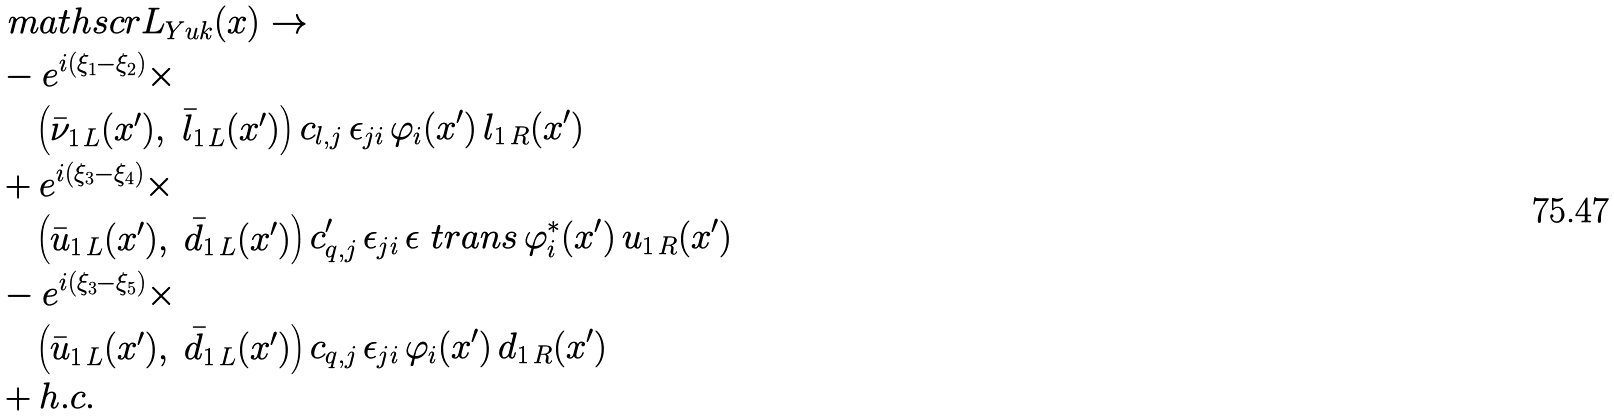Convert formula to latex. <formula><loc_0><loc_0><loc_500><loc_500>& \ m a t h s c r { L } _ { Y u k } ( x ) \rightarrow \\ & - e ^ { i ( \xi _ { 1 } - \xi _ { 2 } ) } \times \\ & \quad \begin{pmatrix} \bar { \nu } _ { 1 \, L } ( x ^ { \prime } ) , & \bar { l } _ { 1 \, L } ( x ^ { \prime } ) \end{pmatrix} c _ { l , j } \, \epsilon _ { j i } \, \varphi _ { i } ( x ^ { \prime } ) \, l _ { 1 \, R } ( x ^ { \prime } ) \\ & + e ^ { i ( \xi _ { 3 } - \xi _ { 4 } ) } \times \\ & \quad \begin{pmatrix} \bar { u } _ { 1 \, L } ( x ^ { \prime } ) , & \bar { d } _ { 1 \, L } ( x ^ { \prime } ) \end{pmatrix} c ^ { \prime } _ { q , j } \, \epsilon _ { j i } \, \epsilon ^ { \ } t r a n s \, \varphi _ { i } ^ { \ast } ( x ^ { \prime } ) \, u _ { 1 \, R } ( x ^ { \prime } ) \\ & - e ^ { i ( \xi _ { 3 } - \xi _ { 5 } ) } \times \\ & \quad \begin{pmatrix} \bar { u } _ { 1 \, L } ( x ^ { \prime } ) , & \bar { d } _ { 1 \, L } ( x ^ { \prime } ) \end{pmatrix} c _ { q , j } \, \epsilon _ { j i } \, \varphi _ { i } ( x ^ { \prime } ) \, d _ { 1 \, R } ( x ^ { \prime } ) \\ & + h . c .</formula> 